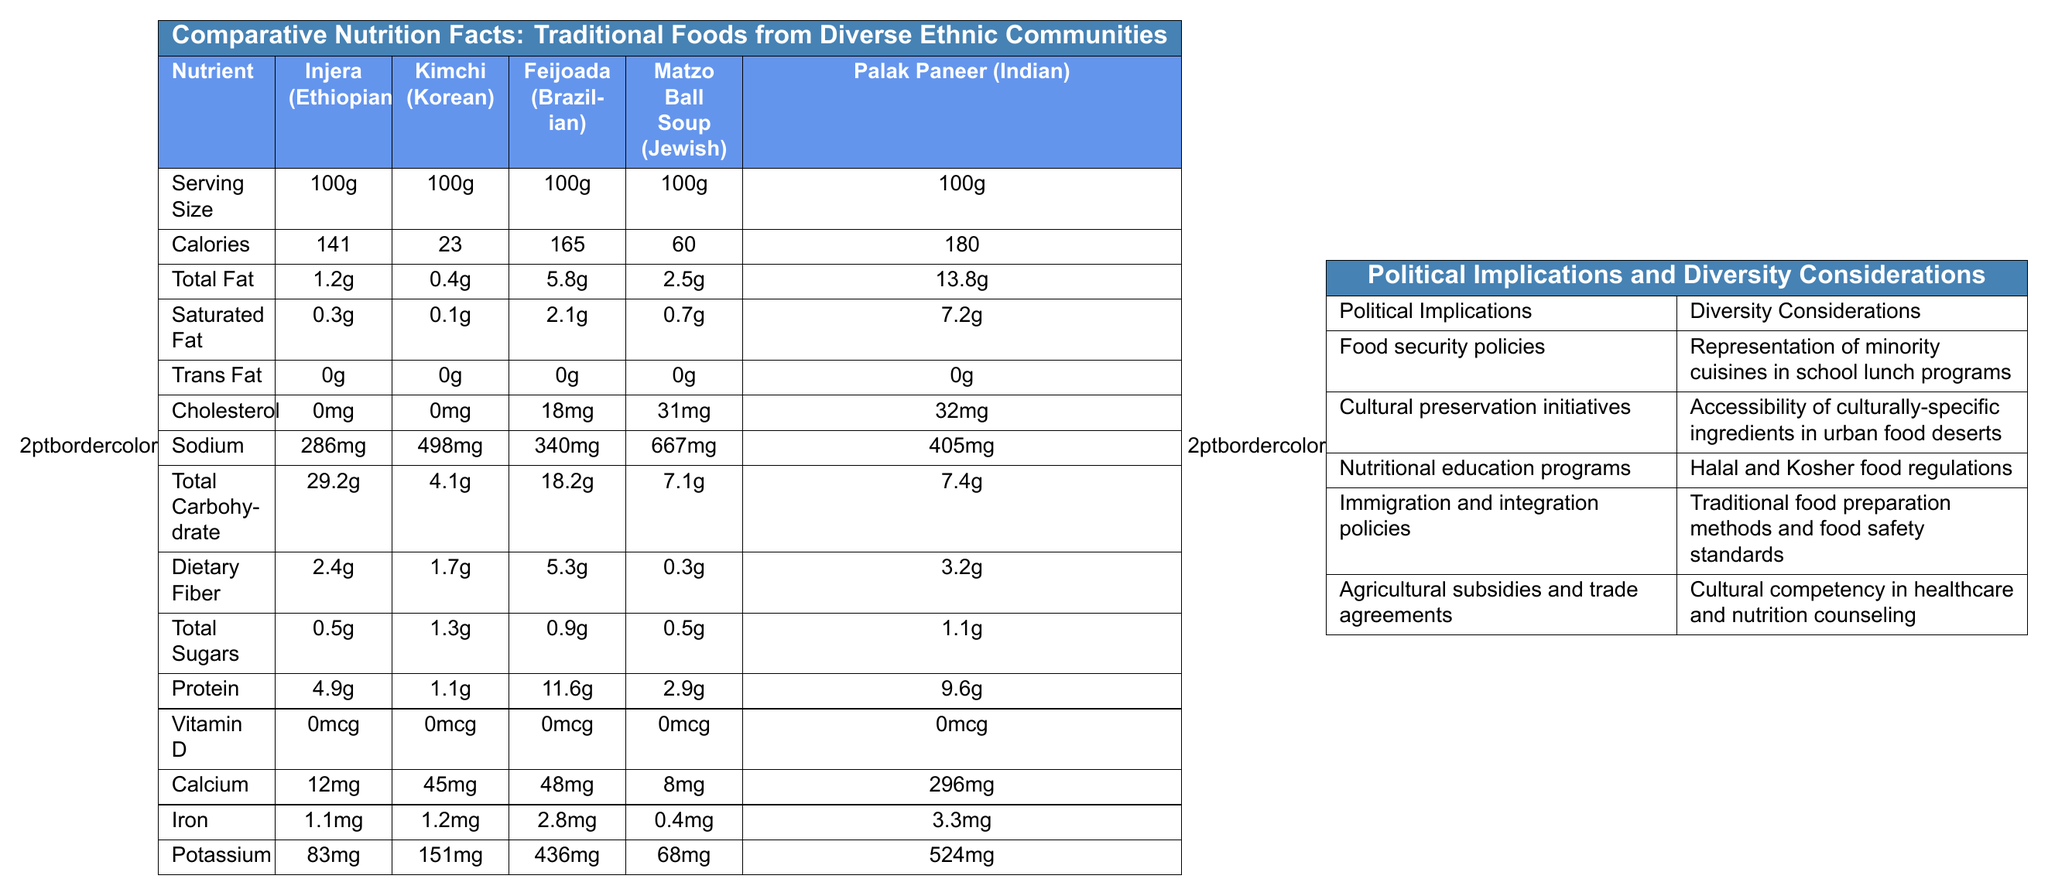what is the serving size for all foods listed? The document clearly states that the serving size for all foods is 100g.
Answer: 100g which food has the highest caloric content per serving? Palak Paneer has the highest caloric content per serving at 180 calories.
Answer: Palak Paneer (Indian) which food contains the most dietary fiber? Feijoada has the most dietary fiber at 5.3g per serving.
Answer: Feijoada (Brazilian) how much sodium is in Kimchi? The document indicates that Kimchi contains 498mg of sodium per serving.
Answer: 498mg which food contains the least protein per serving? Kimchi contains the least protein with 1.1g per serving.
Answer: Kimchi (Korean) which of the following foods has the highest calcium content? A. Injera (Ethiopian) B. Kimchi (Korean) C. Matzo Ball Soup (Jewish) D. Palak Paneer (Indian) Palak Paneer has the highest calcium content with 296mg per serving.
Answer: D. Palak Paneer (Indian) which food has the highest iron content? A. Injera (Ethiopian) B. Feijoada (Brazilian) C. Matzo Ball Soup (Jewish) D. Palak Paneer (Indian) Palak Paneer contains the highest iron content at 3.3mg per serving.
Answer: D. Palak Paneer (Indian) does any food contain trans fat? The document specifies that all foods listed contain 0g of trans fat per serving.
Answer: No summarize the main idea of the document The document includes detailed nutritional data for five traditional foods from different ethnic communities, along with potential political and diversity implications related to food security, cultural preservation, and nutrition education.
Answer: The document provides a comparative analysis of the nutritional facts of traditional foods from diverse ethnic communities, focusing on serving size, caloric content, and various nutrients. It also discusses the political implications and diversity considerations relevant to food security, cultural preservation, and nutrition education. what are the potential political implications mentioned in the document? The document lists these specific political implications as they relate to the nutritional value of traditional foods from diverse ethnic communities.
Answer: Food security policies, Cultural preservation initiatives, Nutritional education programs, Immigration and integration policies, Agricultural subsidies and trade agreements what is the impact of sodium intake on health? The document provides the sodium content of various traditional foods but does not discuss the health impacts of sodium intake.
Answer: Cannot be determined which food has the highest cholesterol content? Matzo Ball Soup has the highest cholesterol content with 31mg per serving.
Answer: Matzo Ball Soup (Jewish) 